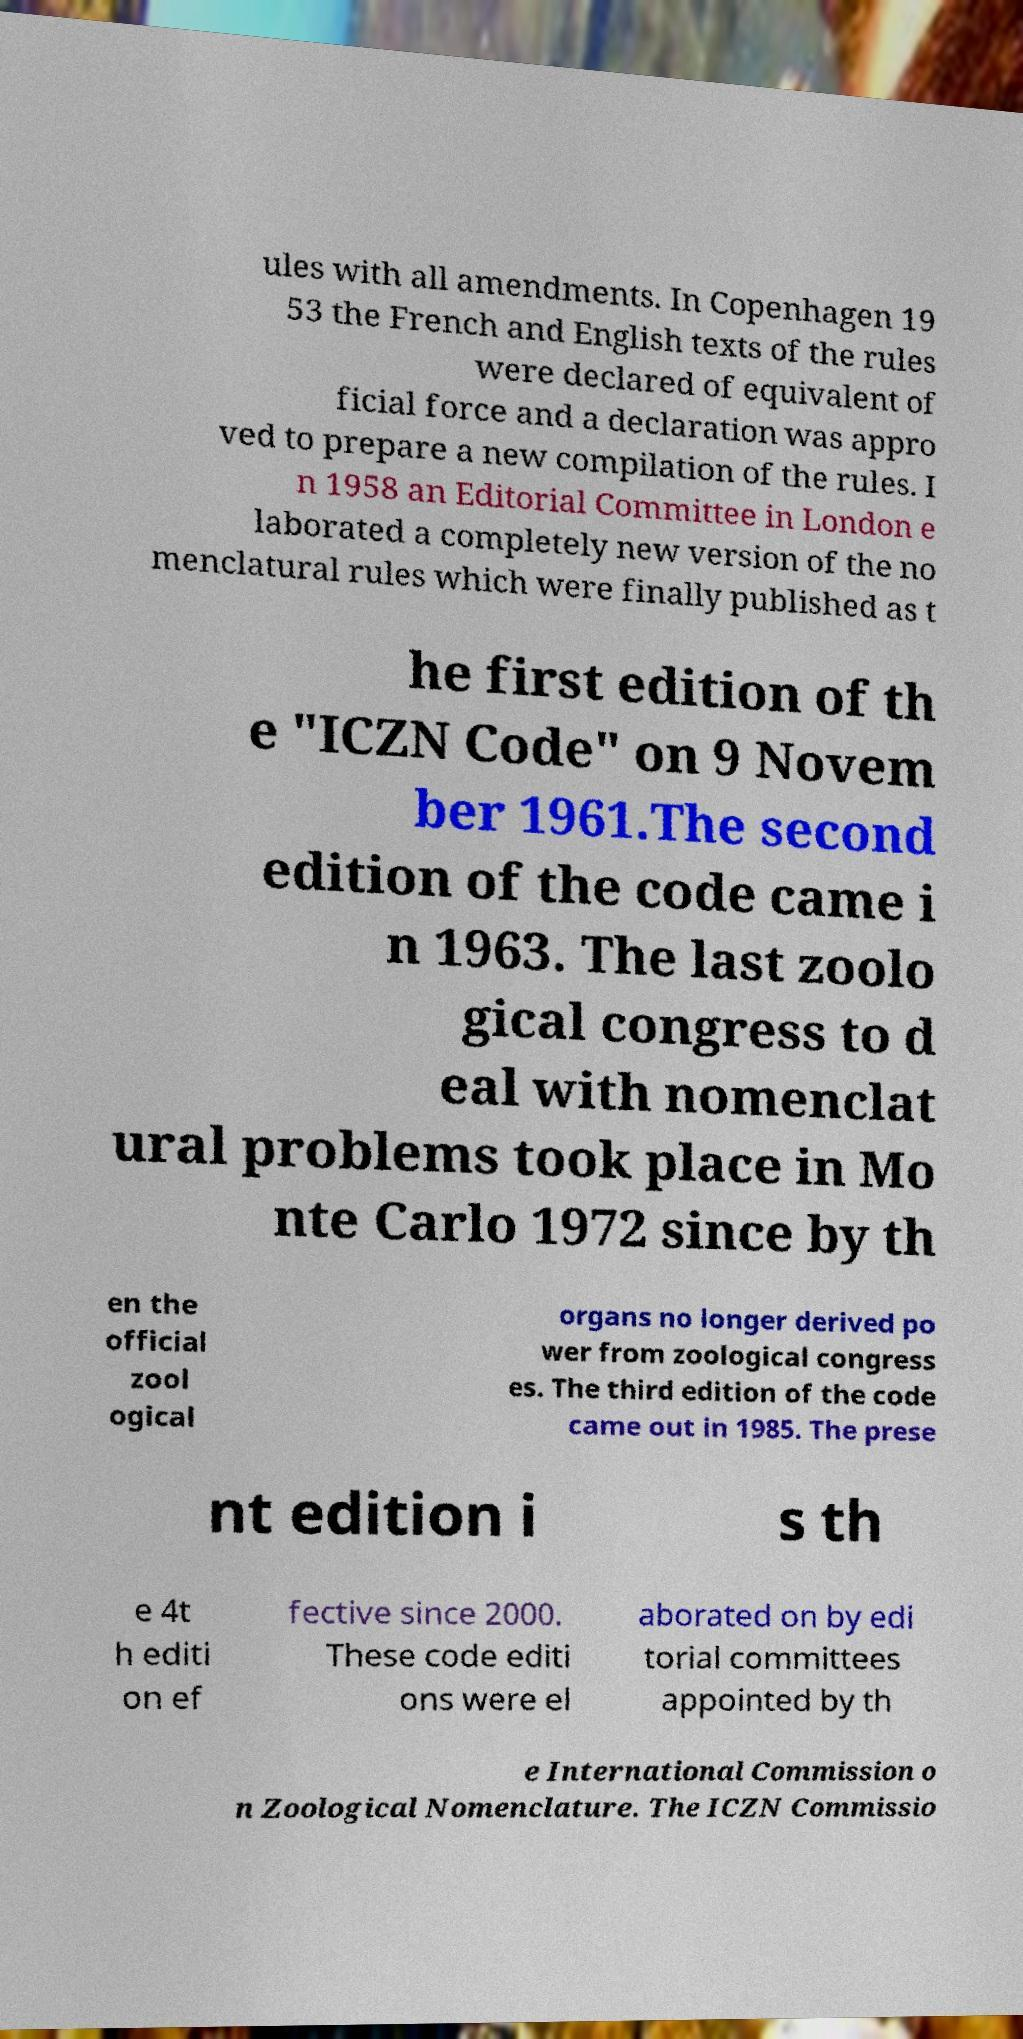I need the written content from this picture converted into text. Can you do that? ules with all amendments. In Copenhagen 19 53 the French and English texts of the rules were declared of equivalent of ficial force and a declaration was appro ved to prepare a new compilation of the rules. I n 1958 an Editorial Committee in London e laborated a completely new version of the no menclatural rules which were finally published as t he first edition of th e "ICZN Code" on 9 Novem ber 1961.The second edition of the code came i n 1963. The last zoolo gical congress to d eal with nomenclat ural problems took place in Mo nte Carlo 1972 since by th en the official zool ogical organs no longer derived po wer from zoological congress es. The third edition of the code came out in 1985. The prese nt edition i s th e 4t h editi on ef fective since 2000. These code editi ons were el aborated on by edi torial committees appointed by th e International Commission o n Zoological Nomenclature. The ICZN Commissio 